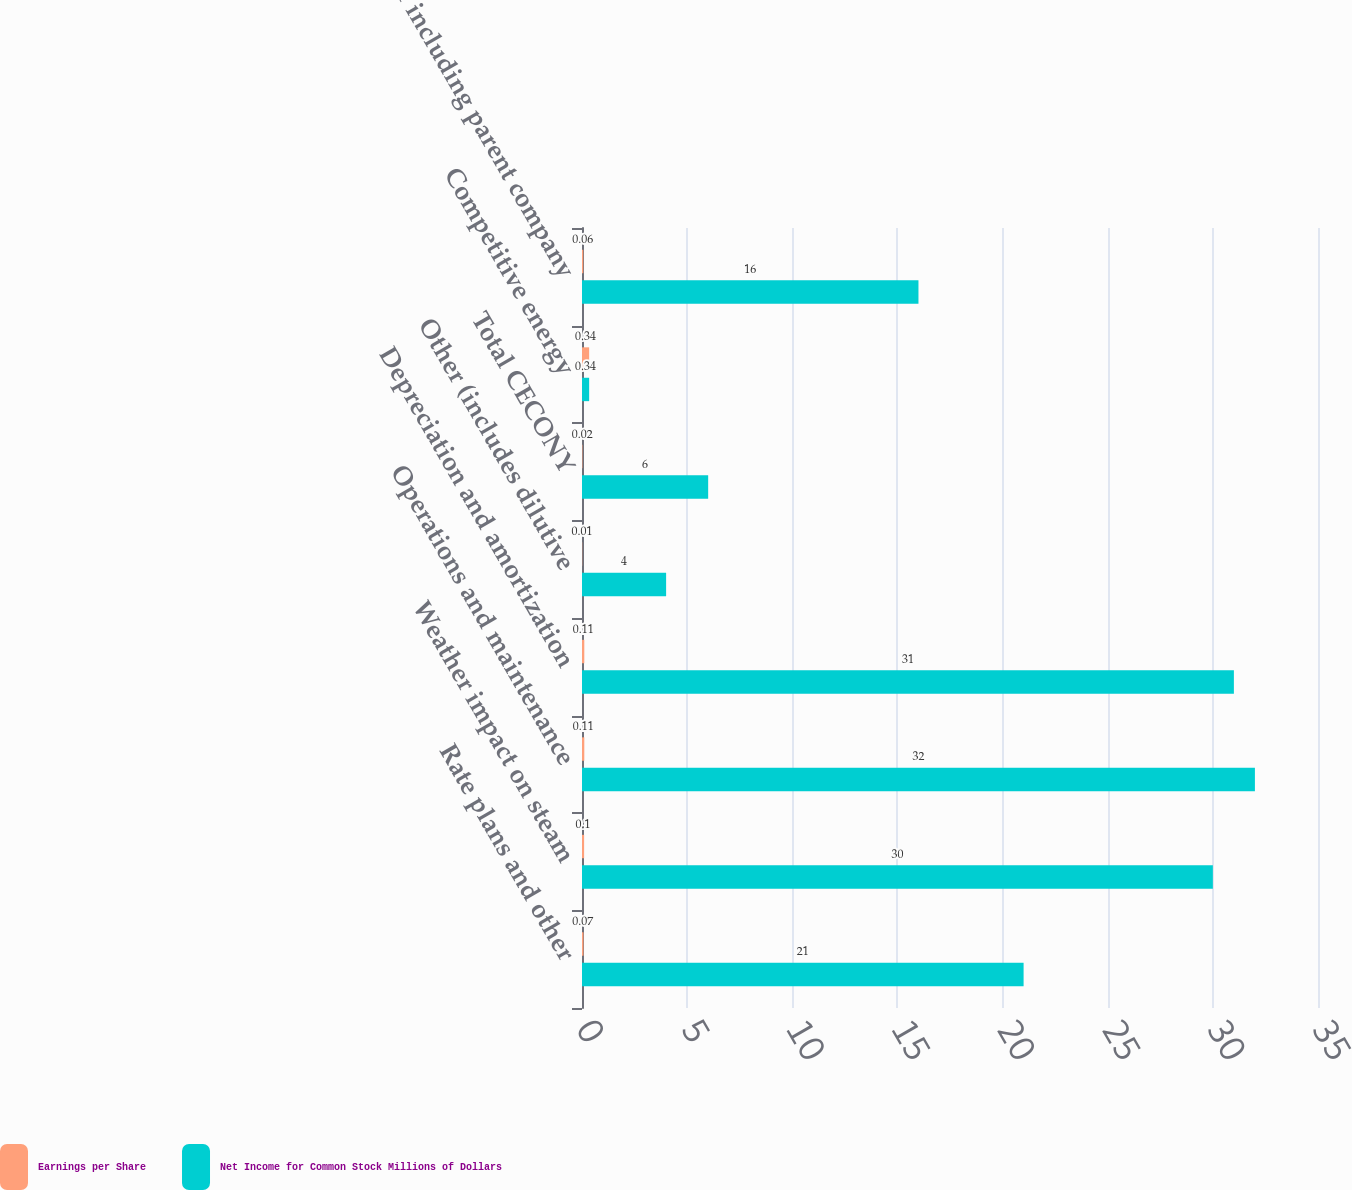Convert chart. <chart><loc_0><loc_0><loc_500><loc_500><stacked_bar_chart><ecel><fcel>Rate plans and other<fcel>Weather impact on steam<fcel>Operations and maintenance<fcel>Depreciation and amortization<fcel>Other (includes dilutive<fcel>Total CECONY<fcel>Competitive energy<fcel>Other including parent company<nl><fcel>Earnings per Share<fcel>0.07<fcel>0.1<fcel>0.11<fcel>0.11<fcel>0.01<fcel>0.02<fcel>0.34<fcel>0.06<nl><fcel>Net Income for Common Stock Millions of Dollars<fcel>21<fcel>30<fcel>32<fcel>31<fcel>4<fcel>6<fcel>0.34<fcel>16<nl></chart> 